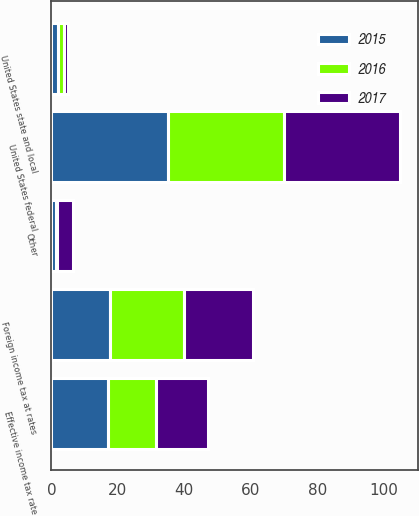Convert chart. <chart><loc_0><loc_0><loc_500><loc_500><stacked_bar_chart><ecel><fcel>United States federal<fcel>United States state and local<fcel>Foreign income tax at rates<fcel>Other<fcel>Effective income tax rate<nl><fcel>2017<fcel>35<fcel>1.2<fcel>21<fcel>4.9<fcel>15.7<nl><fcel>2016<fcel>35<fcel>1.7<fcel>22.2<fcel>0.1<fcel>14.3<nl><fcel>2015<fcel>35<fcel>2.1<fcel>17.6<fcel>1.5<fcel>17.1<nl></chart> 